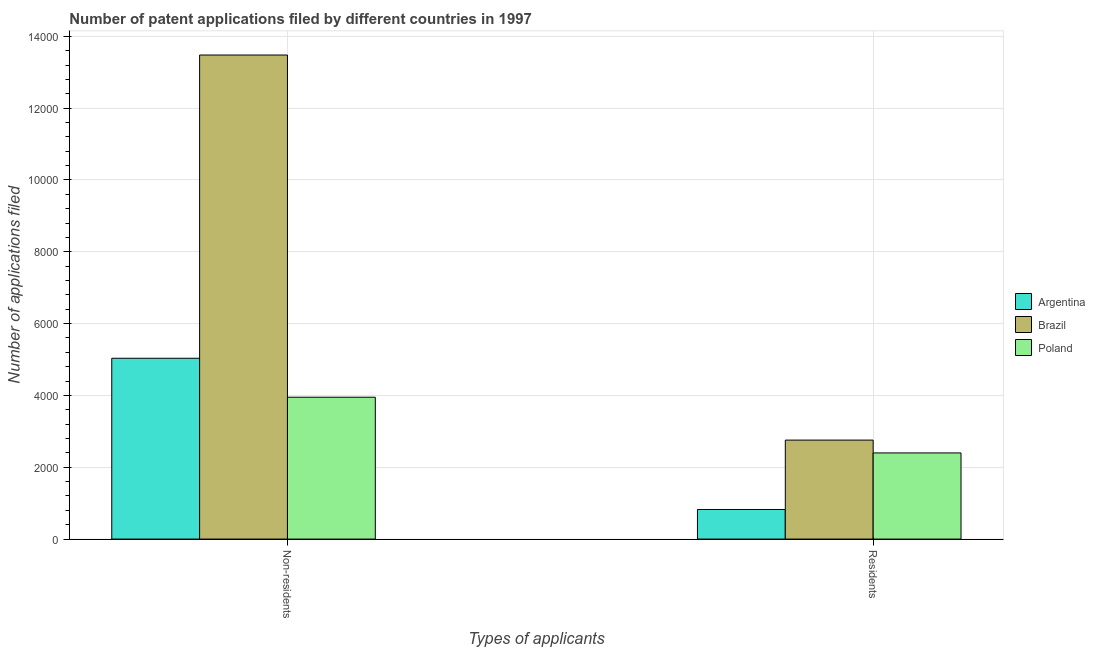How many groups of bars are there?
Your answer should be compact. 2. How many bars are there on the 2nd tick from the right?
Your answer should be very brief. 3. What is the label of the 1st group of bars from the left?
Your answer should be very brief. Non-residents. What is the number of patent applications by residents in Brazil?
Ensure brevity in your answer.  2756. Across all countries, what is the maximum number of patent applications by non residents?
Ensure brevity in your answer.  1.35e+04. Across all countries, what is the minimum number of patent applications by residents?
Make the answer very short. 824. What is the total number of patent applications by residents in the graph?
Offer a terse response. 5979. What is the difference between the number of patent applications by residents in Argentina and that in Poland?
Your answer should be compact. -1575. What is the difference between the number of patent applications by non residents in Argentina and the number of patent applications by residents in Poland?
Your answer should be very brief. 2636. What is the average number of patent applications by residents per country?
Offer a very short reply. 1993. What is the difference between the number of patent applications by non residents and number of patent applications by residents in Brazil?
Offer a terse response. 1.07e+04. What is the ratio of the number of patent applications by residents in Poland to that in Argentina?
Offer a very short reply. 2.91. Is the number of patent applications by residents in Argentina less than that in Brazil?
Make the answer very short. Yes. How many bars are there?
Offer a very short reply. 6. How many countries are there in the graph?
Your response must be concise. 3. What is the difference between two consecutive major ticks on the Y-axis?
Offer a very short reply. 2000. Are the values on the major ticks of Y-axis written in scientific E-notation?
Your answer should be very brief. No. Does the graph contain grids?
Make the answer very short. Yes. Where does the legend appear in the graph?
Provide a succinct answer. Center right. What is the title of the graph?
Offer a terse response. Number of patent applications filed by different countries in 1997. What is the label or title of the X-axis?
Offer a terse response. Types of applicants. What is the label or title of the Y-axis?
Your answer should be compact. Number of applications filed. What is the Number of applications filed of Argentina in Non-residents?
Your answer should be compact. 5035. What is the Number of applications filed in Brazil in Non-residents?
Offer a very short reply. 1.35e+04. What is the Number of applications filed in Poland in Non-residents?
Make the answer very short. 3950. What is the Number of applications filed in Argentina in Residents?
Provide a short and direct response. 824. What is the Number of applications filed in Brazil in Residents?
Give a very brief answer. 2756. What is the Number of applications filed in Poland in Residents?
Provide a succinct answer. 2399. Across all Types of applicants, what is the maximum Number of applications filed in Argentina?
Ensure brevity in your answer.  5035. Across all Types of applicants, what is the maximum Number of applications filed in Brazil?
Ensure brevity in your answer.  1.35e+04. Across all Types of applicants, what is the maximum Number of applications filed of Poland?
Your answer should be very brief. 3950. Across all Types of applicants, what is the minimum Number of applications filed in Argentina?
Give a very brief answer. 824. Across all Types of applicants, what is the minimum Number of applications filed of Brazil?
Provide a short and direct response. 2756. Across all Types of applicants, what is the minimum Number of applications filed of Poland?
Ensure brevity in your answer.  2399. What is the total Number of applications filed in Argentina in the graph?
Your answer should be very brief. 5859. What is the total Number of applications filed in Brazil in the graph?
Make the answer very short. 1.62e+04. What is the total Number of applications filed of Poland in the graph?
Your answer should be compact. 6349. What is the difference between the Number of applications filed of Argentina in Non-residents and that in Residents?
Your answer should be compact. 4211. What is the difference between the Number of applications filed in Brazil in Non-residents and that in Residents?
Your answer should be very brief. 1.07e+04. What is the difference between the Number of applications filed in Poland in Non-residents and that in Residents?
Provide a short and direct response. 1551. What is the difference between the Number of applications filed in Argentina in Non-residents and the Number of applications filed in Brazil in Residents?
Provide a short and direct response. 2279. What is the difference between the Number of applications filed of Argentina in Non-residents and the Number of applications filed of Poland in Residents?
Ensure brevity in your answer.  2636. What is the difference between the Number of applications filed in Brazil in Non-residents and the Number of applications filed in Poland in Residents?
Provide a succinct answer. 1.11e+04. What is the average Number of applications filed in Argentina per Types of applicants?
Provide a short and direct response. 2929.5. What is the average Number of applications filed in Brazil per Types of applicants?
Give a very brief answer. 8117.5. What is the average Number of applications filed of Poland per Types of applicants?
Make the answer very short. 3174.5. What is the difference between the Number of applications filed in Argentina and Number of applications filed in Brazil in Non-residents?
Keep it short and to the point. -8444. What is the difference between the Number of applications filed of Argentina and Number of applications filed of Poland in Non-residents?
Make the answer very short. 1085. What is the difference between the Number of applications filed in Brazil and Number of applications filed in Poland in Non-residents?
Your response must be concise. 9529. What is the difference between the Number of applications filed in Argentina and Number of applications filed in Brazil in Residents?
Keep it short and to the point. -1932. What is the difference between the Number of applications filed in Argentina and Number of applications filed in Poland in Residents?
Keep it short and to the point. -1575. What is the difference between the Number of applications filed in Brazil and Number of applications filed in Poland in Residents?
Provide a succinct answer. 357. What is the ratio of the Number of applications filed of Argentina in Non-residents to that in Residents?
Offer a very short reply. 6.11. What is the ratio of the Number of applications filed of Brazil in Non-residents to that in Residents?
Make the answer very short. 4.89. What is the ratio of the Number of applications filed of Poland in Non-residents to that in Residents?
Your answer should be compact. 1.65. What is the difference between the highest and the second highest Number of applications filed of Argentina?
Offer a terse response. 4211. What is the difference between the highest and the second highest Number of applications filed of Brazil?
Ensure brevity in your answer.  1.07e+04. What is the difference between the highest and the second highest Number of applications filed of Poland?
Make the answer very short. 1551. What is the difference between the highest and the lowest Number of applications filed in Argentina?
Make the answer very short. 4211. What is the difference between the highest and the lowest Number of applications filed of Brazil?
Provide a short and direct response. 1.07e+04. What is the difference between the highest and the lowest Number of applications filed in Poland?
Provide a short and direct response. 1551. 